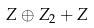<formula> <loc_0><loc_0><loc_500><loc_500>Z \oplus Z _ { 2 } + Z</formula> 